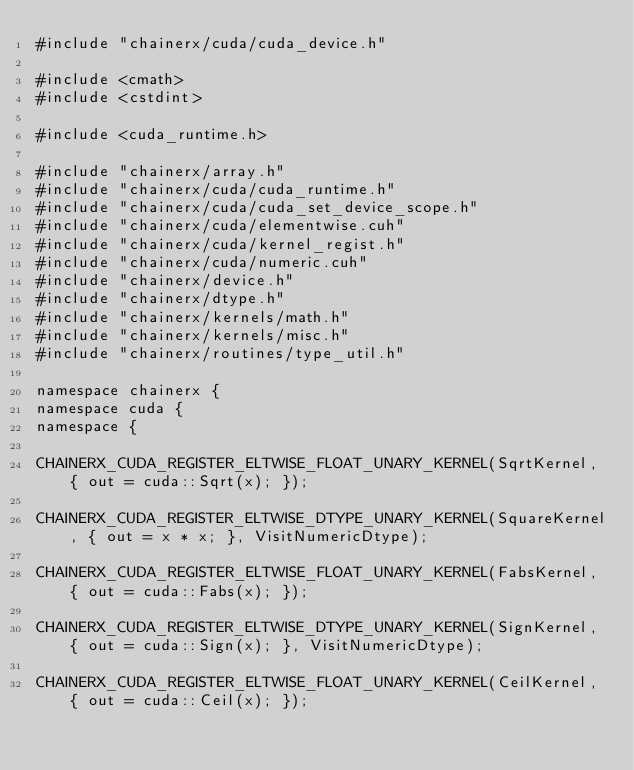Convert code to text. <code><loc_0><loc_0><loc_500><loc_500><_Cuda_>#include "chainerx/cuda/cuda_device.h"

#include <cmath>
#include <cstdint>

#include <cuda_runtime.h>

#include "chainerx/array.h"
#include "chainerx/cuda/cuda_runtime.h"
#include "chainerx/cuda/cuda_set_device_scope.h"
#include "chainerx/cuda/elementwise.cuh"
#include "chainerx/cuda/kernel_regist.h"
#include "chainerx/cuda/numeric.cuh"
#include "chainerx/device.h"
#include "chainerx/dtype.h"
#include "chainerx/kernels/math.h"
#include "chainerx/kernels/misc.h"
#include "chainerx/routines/type_util.h"

namespace chainerx {
namespace cuda {
namespace {

CHAINERX_CUDA_REGISTER_ELTWISE_FLOAT_UNARY_KERNEL(SqrtKernel, { out = cuda::Sqrt(x); });

CHAINERX_CUDA_REGISTER_ELTWISE_DTYPE_UNARY_KERNEL(SquareKernel, { out = x * x; }, VisitNumericDtype);

CHAINERX_CUDA_REGISTER_ELTWISE_FLOAT_UNARY_KERNEL(FabsKernel, { out = cuda::Fabs(x); });

CHAINERX_CUDA_REGISTER_ELTWISE_DTYPE_UNARY_KERNEL(SignKernel, { out = cuda::Sign(x); }, VisitNumericDtype);

CHAINERX_CUDA_REGISTER_ELTWISE_FLOAT_UNARY_KERNEL(CeilKernel, { out = cuda::Ceil(x); });
</code> 